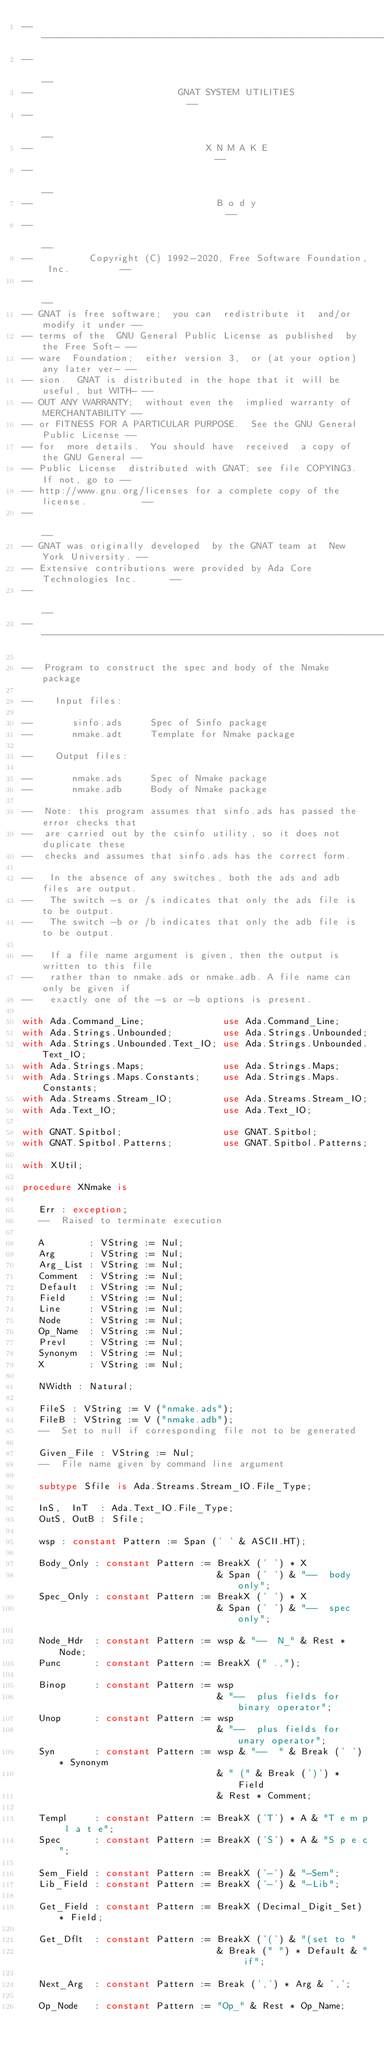<code> <loc_0><loc_0><loc_500><loc_500><_Ada_>------------------------------------------------------------------------------
--                                                                          --
--                          GNAT SYSTEM UTILITIES                           --
--                                                                          --
--                               X N M A K E                                --
--                                                                          --
--                                 B o d y                                  --
--                                                                          --
--          Copyright (C) 1992-2020, Free Software Foundation, Inc.         --
--                                                                          --
-- GNAT is free software;  you can  redistribute it  and/or modify it under --
-- terms of the  GNU General Public License as published  by the Free Soft- --
-- ware  Foundation;  either version 3,  or (at your option) any later ver- --
-- sion.  GNAT is distributed in the hope that it will be useful, but WITH- --
-- OUT ANY WARRANTY;  without even the  implied warranty of MERCHANTABILITY --
-- or FITNESS FOR A PARTICULAR PURPOSE.  See the GNU General Public License --
-- for  more details.  You should have  received  a copy of the GNU General --
-- Public License  distributed with GNAT; see file COPYING3.  If not, go to --
-- http://www.gnu.org/licenses for a complete copy of the license.          --
--                                                                          --
-- GNAT was originally developed  by the GNAT team at  New York University. --
-- Extensive contributions were provided by Ada Core Technologies Inc.      --
--                                                                          --
------------------------------------------------------------------------------

--  Program to construct the spec and body of the Nmake package

--    Input files:

--       sinfo.ads     Spec of Sinfo package
--       nmake.adt     Template for Nmake package

--    Output files:

--       nmake.ads     Spec of Nmake package
--       nmake.adb     Body of Nmake package

--  Note: this program assumes that sinfo.ads has passed the error checks that
--  are carried out by the csinfo utility, so it does not duplicate these
--  checks and assumes that sinfo.ads has the correct form.

--   In the absence of any switches, both the ads and adb files are output.
--   The switch -s or /s indicates that only the ads file is to be output.
--   The switch -b or /b indicates that only the adb file is to be output.

--   If a file name argument is given, then the output is written to this file
--   rather than to nmake.ads or nmake.adb. A file name can only be given if
--   exactly one of the -s or -b options is present.

with Ada.Command_Line;              use Ada.Command_Line;
with Ada.Strings.Unbounded;         use Ada.Strings.Unbounded;
with Ada.Strings.Unbounded.Text_IO; use Ada.Strings.Unbounded.Text_IO;
with Ada.Strings.Maps;              use Ada.Strings.Maps;
with Ada.Strings.Maps.Constants;    use Ada.Strings.Maps.Constants;
with Ada.Streams.Stream_IO;         use Ada.Streams.Stream_IO;
with Ada.Text_IO;                   use Ada.Text_IO;

with GNAT.Spitbol;                  use GNAT.Spitbol;
with GNAT.Spitbol.Patterns;         use GNAT.Spitbol.Patterns;

with XUtil;

procedure XNmake is

   Err : exception;
   --  Raised to terminate execution

   A        : VString := Nul;
   Arg      : VString := Nul;
   Arg_List : VString := Nul;
   Comment  : VString := Nul;
   Default  : VString := Nul;
   Field    : VString := Nul;
   Line     : VString := Nul;
   Node     : VString := Nul;
   Op_Name  : VString := Nul;
   Prevl    : VString := Nul;
   Synonym  : VString := Nul;
   X        : VString := Nul;

   NWidth : Natural;

   FileS : VString := V ("nmake.ads");
   FileB : VString := V ("nmake.adb");
   --  Set to null if corresponding file not to be generated

   Given_File : VString := Nul;
   --  File name given by command line argument

   subtype Sfile is Ada.Streams.Stream_IO.File_Type;

   InS,  InT  : Ada.Text_IO.File_Type;
   OutS, OutB : Sfile;

   wsp : constant Pattern := Span (' ' & ASCII.HT);

   Body_Only : constant Pattern := BreakX (' ') * X
                                   & Span (' ') & "--  body only";
   Spec_Only : constant Pattern := BreakX (' ') * X
                                   & Span (' ') & "--  spec only";

   Node_Hdr  : constant Pattern := wsp & "--  N_" & Rest * Node;
   Punc      : constant Pattern := BreakX (" .,");

   Binop     : constant Pattern := wsp
                                   & "--  plus fields for binary operator";
   Unop      : constant Pattern := wsp
                                   & "--  plus fields for unary operator";
   Syn       : constant Pattern := wsp & "--  " & Break (' ') * Synonym
                                   & " (" & Break (')') * Field
                                   & Rest * Comment;

   Templ     : constant Pattern := BreakX ('T') * A & "T e m p l a t e";
   Spec      : constant Pattern := BreakX ('S') * A & "S p e c";

   Sem_Field : constant Pattern := BreakX ('-') & "-Sem";
   Lib_Field : constant Pattern := BreakX ('-') & "-Lib";

   Get_Field : constant Pattern := BreakX (Decimal_Digit_Set) * Field;

   Get_Dflt  : constant Pattern := BreakX ('(') & "(set to "
                                   & Break (" ") * Default & " if";

   Next_Arg  : constant Pattern := Break (',') * Arg & ',';

   Op_Node   : constant Pattern := "Op_" & Rest * Op_Name;
</code> 